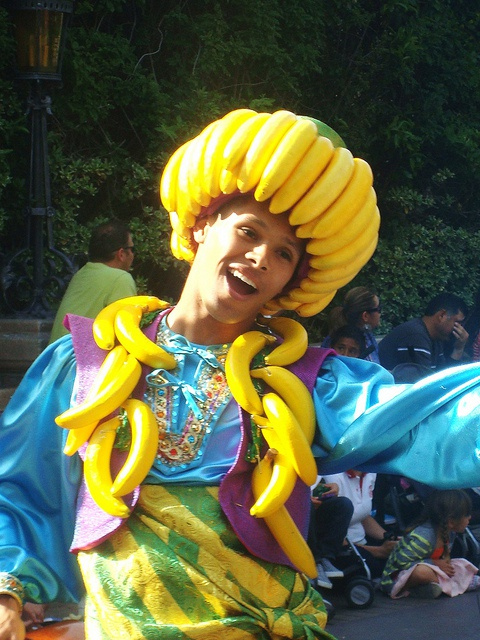Describe the objects in this image and their specific colors. I can see people in black, orange, yellow, ivory, and olive tones, banana in black, orange, yellow, and olive tones, people in black, gray, and navy tones, people in black, olive, and green tones, and people in black, navy, gray, and blue tones in this image. 